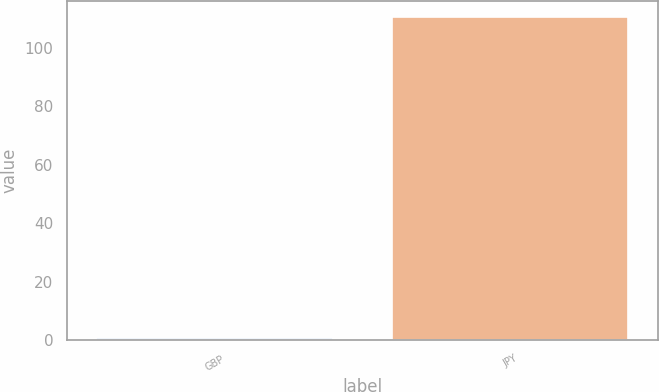Convert chart to OTSL. <chart><loc_0><loc_0><loc_500><loc_500><bar_chart><fcel>GBP<fcel>JPY<nl><fcel>0.75<fcel>110.5<nl></chart> 